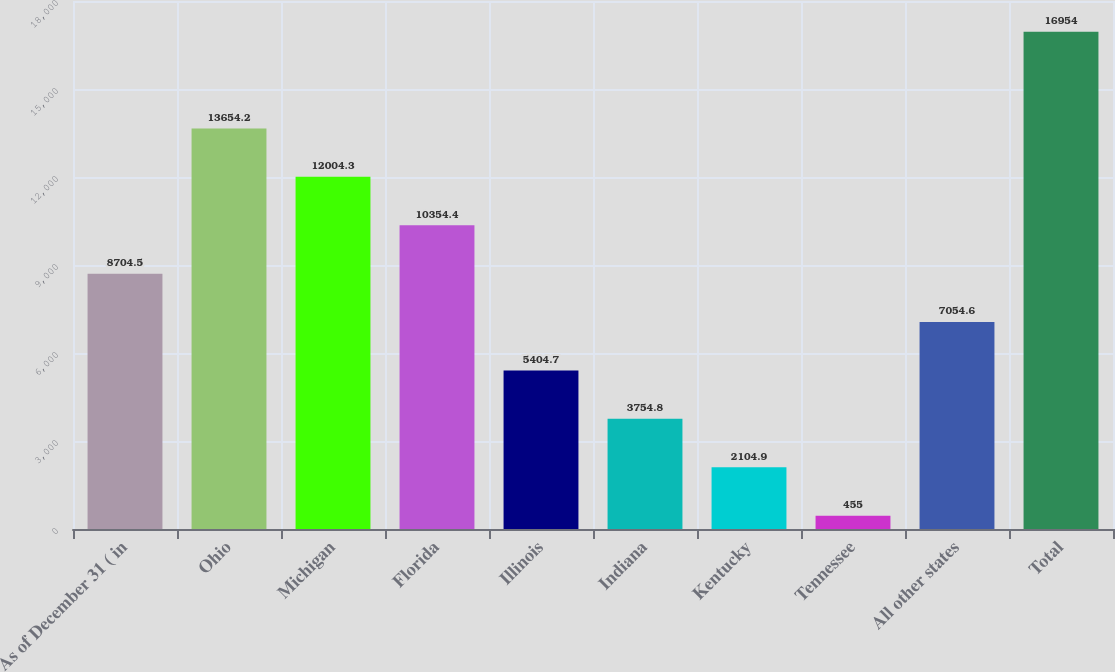Convert chart. <chart><loc_0><loc_0><loc_500><loc_500><bar_chart><fcel>As of December 31 ( in<fcel>Ohio<fcel>Michigan<fcel>Florida<fcel>Illinois<fcel>Indiana<fcel>Kentucky<fcel>Tennessee<fcel>All other states<fcel>Total<nl><fcel>8704.5<fcel>13654.2<fcel>12004.3<fcel>10354.4<fcel>5404.7<fcel>3754.8<fcel>2104.9<fcel>455<fcel>7054.6<fcel>16954<nl></chart> 